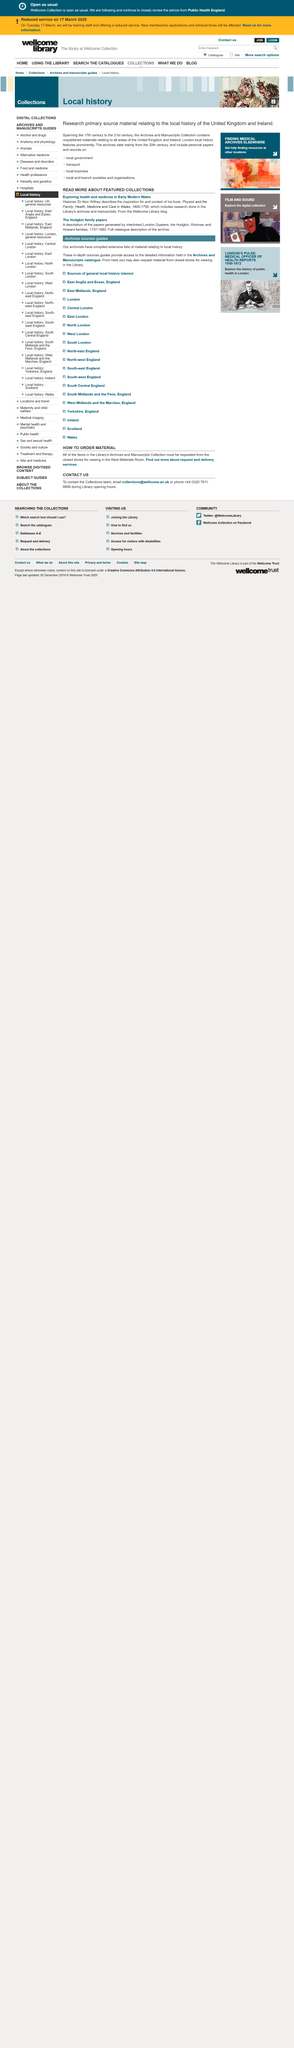Mention a couple of crucial points in this snapshot. We are currently exploring health and medicine in early modern Wales. The historian's name is Dr Alun Withey. The Hodgkin, Rickman, and Howard families are linked to the family papers. These three families are associated with the Hodgkin family papers. 